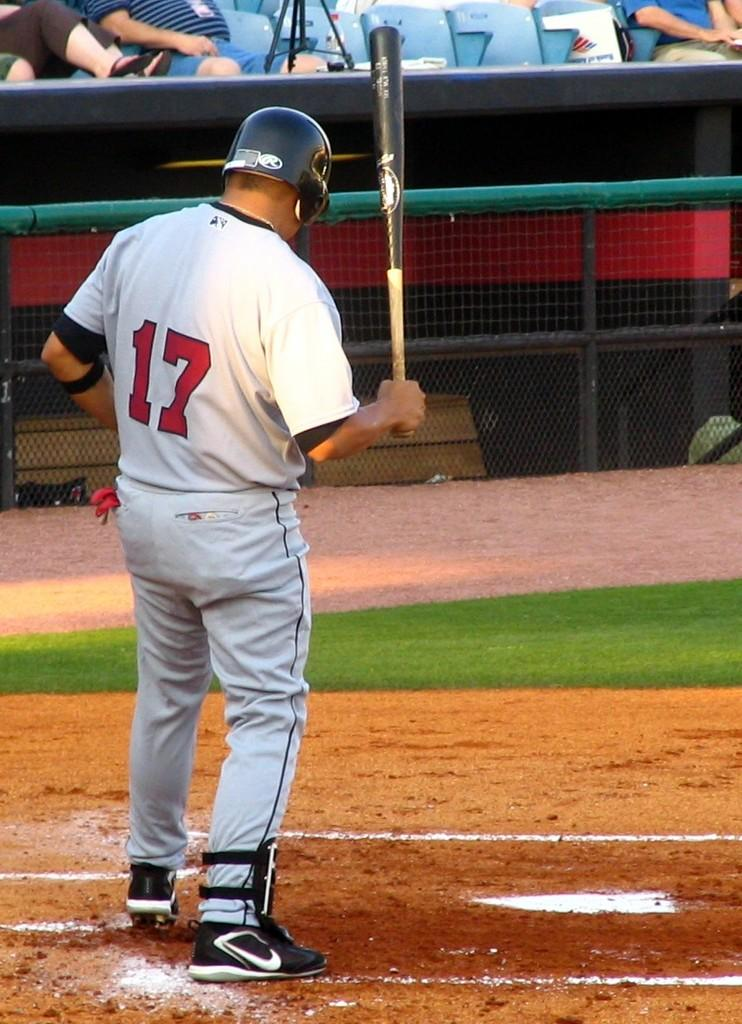What is the person in the image wearing? The person is wearing a white dress and a black helmet. What object is the person holding in the image? The person is holding a bat. What can be seen in the background of the image? There is fencing visible in the background of the image, and there are other people sitting. What might the person be doing with the bat? The person might be playing a sport or engaging in an activity that involves using a bat. What type of glass can be seen in the person's hand in the image? There is no glass visible in the person's hand in the image; they are holding a bat. What is the person's interest in bananas, as seen in the image? There is no mention of bananas or any indication of the person's interests in the image. 